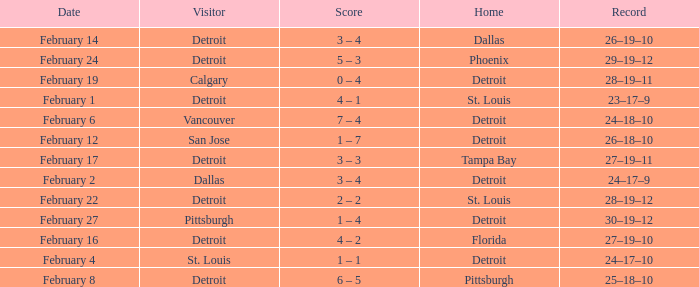What was their record when they were at Pittsburgh? 25–18–10. 